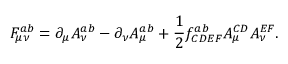<formula> <loc_0><loc_0><loc_500><loc_500>F _ { \mu \nu } ^ { a b } = \partial _ { \mu } A _ { \nu } ^ { a b } - \partial _ { \nu } A _ { \mu } ^ { a b } + \frac { 1 } { 2 } f _ { C D E F } ^ { a b } A _ { \mu } ^ { C D } A _ { \nu } ^ { E F } .</formula> 